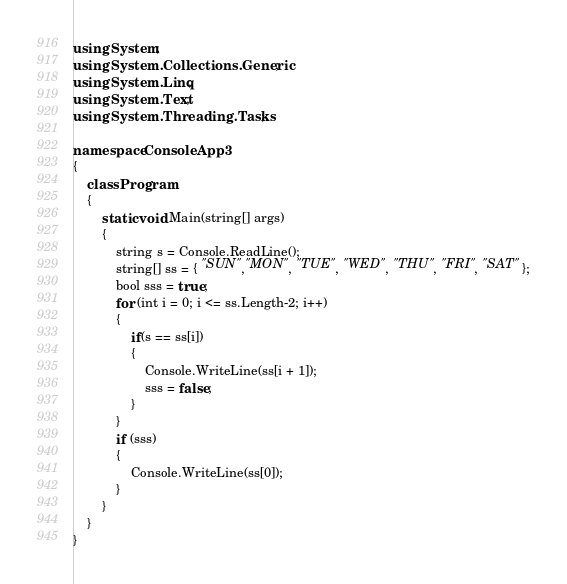Convert code to text. <code><loc_0><loc_0><loc_500><loc_500><_C#_>using System;
using System.Collections.Generic;
using System.Linq;
using System.Text;
using System.Threading.Tasks;

namespace ConsoleApp3
{
    class Program
    {
        static void Main(string[] args)
        {
            string s = Console.ReadLine();
            string[] ss = { "SUN","MON", "TUE", "WED", "THU", "FRI", "SAT" };
            bool sss = true;
            for (int i = 0; i <= ss.Length-2; i++)
            {
                if(s == ss[i])
                {
                    Console.WriteLine(ss[i + 1]);
                    sss = false;
                }
            }
            if (sss)
            {
                Console.WriteLine(ss[0]);
            }
        }
    }
}
</code> 